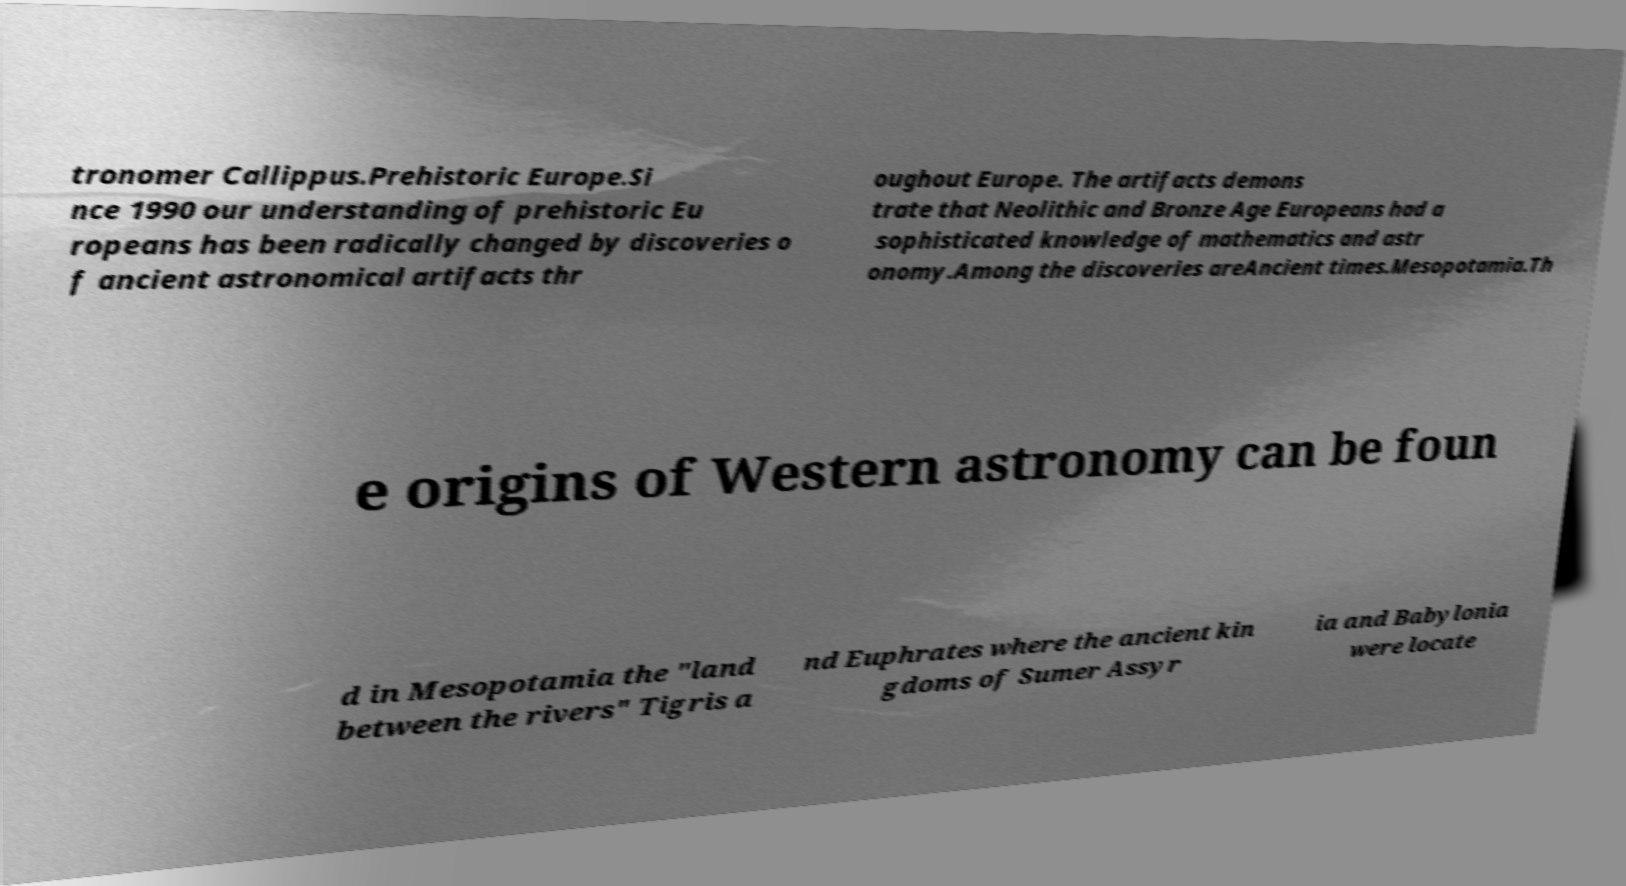There's text embedded in this image that I need extracted. Can you transcribe it verbatim? tronomer Callippus.Prehistoric Europe.Si nce 1990 our understanding of prehistoric Eu ropeans has been radically changed by discoveries o f ancient astronomical artifacts thr oughout Europe. The artifacts demons trate that Neolithic and Bronze Age Europeans had a sophisticated knowledge of mathematics and astr onomy.Among the discoveries areAncient times.Mesopotamia.Th e origins of Western astronomy can be foun d in Mesopotamia the "land between the rivers" Tigris a nd Euphrates where the ancient kin gdoms of Sumer Assyr ia and Babylonia were locate 